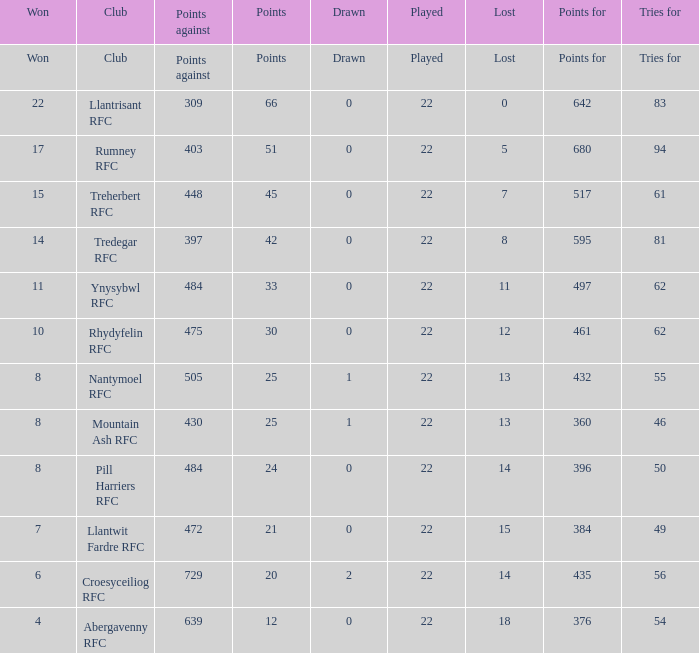How many points for were scored by the team that won exactly 22? 642.0. 